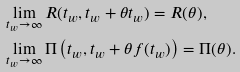<formula> <loc_0><loc_0><loc_500><loc_500>& \lim _ { t _ { w } \to \infty } R ( t _ { w } , t _ { w } + \theta t _ { w } ) = R ( \theta ) , \\ & \lim _ { t _ { w } \to \infty } \Pi \left ( t _ { w } , t _ { w } + \theta f ( t _ { w } ) \right ) = \Pi ( \theta ) .</formula> 